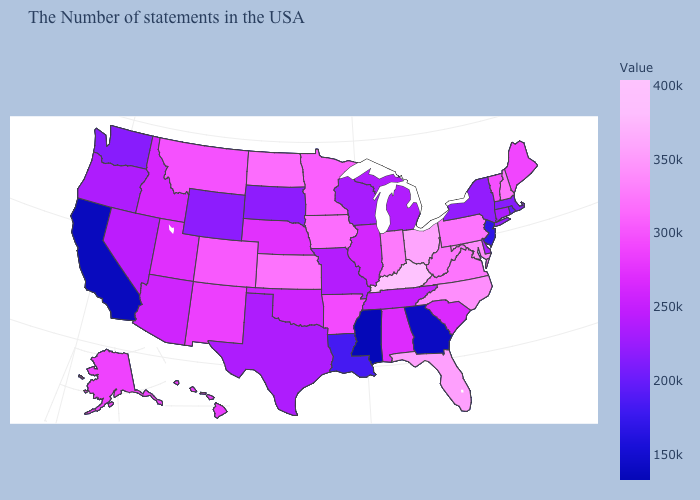Which states have the lowest value in the USA?
Quick response, please. Mississippi. Does Mississippi have the lowest value in the USA?
Quick response, please. Yes. Which states hav the highest value in the West?
Short answer required. Colorado. Among the states that border South Dakota , which have the lowest value?
Answer briefly. Wyoming. Does South Dakota have the lowest value in the MidWest?
Short answer required. Yes. Does the map have missing data?
Be succinct. No. Does Kentucky have the highest value in the USA?
Write a very short answer. Yes. Among the states that border New York , which have the lowest value?
Write a very short answer. New Jersey. Does Colorado have the highest value in the West?
Concise answer only. Yes. 